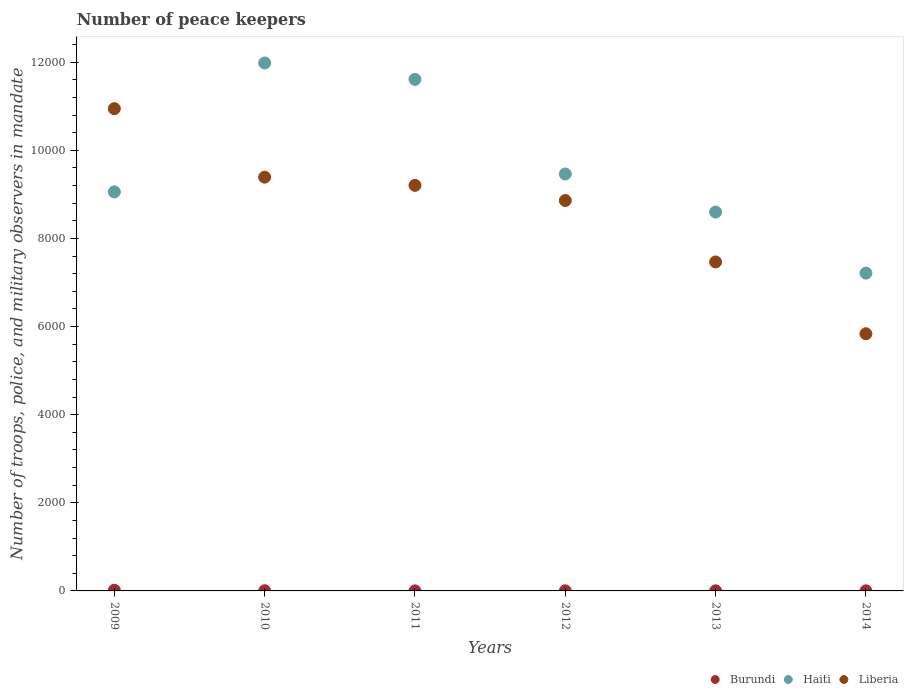How many different coloured dotlines are there?
Provide a succinct answer. 3. Across all years, what is the maximum number of peace keepers in in Haiti?
Offer a terse response. 1.20e+04. Across all years, what is the minimum number of peace keepers in in Haiti?
Offer a very short reply. 7213. What is the total number of peace keepers in in Liberia in the graph?
Your response must be concise. 5.17e+04. What is the difference between the number of peace keepers in in Liberia in 2012 and that in 2014?
Your response must be concise. 3024. What is the difference between the number of peace keepers in in Liberia in 2009 and the number of peace keepers in in Burundi in 2012?
Provide a succinct answer. 1.09e+04. What is the average number of peace keepers in in Haiti per year?
Provide a short and direct response. 9654.83. In the year 2013, what is the difference between the number of peace keepers in in Haiti and number of peace keepers in in Burundi?
Your answer should be compact. 8598. In how many years, is the number of peace keepers in in Liberia greater than 11600?
Provide a short and direct response. 0. What is the ratio of the number of peace keepers in in Haiti in 2010 to that in 2012?
Ensure brevity in your answer.  1.27. Is the number of peace keepers in in Liberia in 2013 less than that in 2014?
Keep it short and to the point. No. What is the difference between the highest and the second highest number of peace keepers in in Burundi?
Your answer should be compact. 11. Is the number of peace keepers in in Liberia strictly less than the number of peace keepers in in Haiti over the years?
Provide a succinct answer. No. How many dotlines are there?
Offer a very short reply. 3. Does the graph contain grids?
Your response must be concise. No. Where does the legend appear in the graph?
Provide a short and direct response. Bottom right. What is the title of the graph?
Provide a short and direct response. Number of peace keepers. Does "Belize" appear as one of the legend labels in the graph?
Your response must be concise. No. What is the label or title of the X-axis?
Your response must be concise. Years. What is the label or title of the Y-axis?
Ensure brevity in your answer.  Number of troops, police, and military observers in mandate. What is the Number of troops, police, and military observers in mandate in Burundi in 2009?
Offer a terse response. 15. What is the Number of troops, police, and military observers in mandate in Haiti in 2009?
Ensure brevity in your answer.  9057. What is the Number of troops, police, and military observers in mandate in Liberia in 2009?
Provide a short and direct response. 1.09e+04. What is the Number of troops, police, and military observers in mandate in Haiti in 2010?
Keep it short and to the point. 1.20e+04. What is the Number of troops, police, and military observers in mandate of Liberia in 2010?
Ensure brevity in your answer.  9392. What is the Number of troops, police, and military observers in mandate in Burundi in 2011?
Ensure brevity in your answer.  1. What is the Number of troops, police, and military observers in mandate in Haiti in 2011?
Your answer should be very brief. 1.16e+04. What is the Number of troops, police, and military observers in mandate in Liberia in 2011?
Offer a very short reply. 9206. What is the Number of troops, police, and military observers in mandate of Haiti in 2012?
Your answer should be very brief. 9464. What is the Number of troops, police, and military observers in mandate of Liberia in 2012?
Offer a very short reply. 8862. What is the Number of troops, police, and military observers in mandate in Burundi in 2013?
Make the answer very short. 2. What is the Number of troops, police, and military observers in mandate of Haiti in 2013?
Give a very brief answer. 8600. What is the Number of troops, police, and military observers in mandate of Liberia in 2013?
Provide a short and direct response. 7467. What is the Number of troops, police, and military observers in mandate of Haiti in 2014?
Offer a very short reply. 7213. What is the Number of troops, police, and military observers in mandate in Liberia in 2014?
Your response must be concise. 5838. Across all years, what is the maximum Number of troops, police, and military observers in mandate in Haiti?
Keep it short and to the point. 1.20e+04. Across all years, what is the maximum Number of troops, police, and military observers in mandate in Liberia?
Keep it short and to the point. 1.09e+04. Across all years, what is the minimum Number of troops, police, and military observers in mandate in Burundi?
Ensure brevity in your answer.  1. Across all years, what is the minimum Number of troops, police, and military observers in mandate of Haiti?
Provide a succinct answer. 7213. Across all years, what is the minimum Number of troops, police, and military observers in mandate in Liberia?
Provide a short and direct response. 5838. What is the total Number of troops, police, and military observers in mandate in Burundi in the graph?
Offer a very short reply. 26. What is the total Number of troops, police, and military observers in mandate of Haiti in the graph?
Give a very brief answer. 5.79e+04. What is the total Number of troops, police, and military observers in mandate in Liberia in the graph?
Provide a short and direct response. 5.17e+04. What is the difference between the Number of troops, police, and military observers in mandate in Haiti in 2009 and that in 2010?
Provide a short and direct response. -2927. What is the difference between the Number of troops, police, and military observers in mandate of Liberia in 2009 and that in 2010?
Your answer should be very brief. 1555. What is the difference between the Number of troops, police, and military observers in mandate in Haiti in 2009 and that in 2011?
Offer a very short reply. -2554. What is the difference between the Number of troops, police, and military observers in mandate in Liberia in 2009 and that in 2011?
Give a very brief answer. 1741. What is the difference between the Number of troops, police, and military observers in mandate in Burundi in 2009 and that in 2012?
Your response must be concise. 13. What is the difference between the Number of troops, police, and military observers in mandate in Haiti in 2009 and that in 2012?
Give a very brief answer. -407. What is the difference between the Number of troops, police, and military observers in mandate in Liberia in 2009 and that in 2012?
Make the answer very short. 2085. What is the difference between the Number of troops, police, and military observers in mandate of Burundi in 2009 and that in 2013?
Offer a terse response. 13. What is the difference between the Number of troops, police, and military observers in mandate in Haiti in 2009 and that in 2013?
Your answer should be compact. 457. What is the difference between the Number of troops, police, and military observers in mandate of Liberia in 2009 and that in 2013?
Offer a very short reply. 3480. What is the difference between the Number of troops, police, and military observers in mandate of Haiti in 2009 and that in 2014?
Provide a succinct answer. 1844. What is the difference between the Number of troops, police, and military observers in mandate in Liberia in 2009 and that in 2014?
Make the answer very short. 5109. What is the difference between the Number of troops, police, and military observers in mandate in Burundi in 2010 and that in 2011?
Offer a terse response. 3. What is the difference between the Number of troops, police, and military observers in mandate of Haiti in 2010 and that in 2011?
Provide a succinct answer. 373. What is the difference between the Number of troops, police, and military observers in mandate of Liberia in 2010 and that in 2011?
Your answer should be very brief. 186. What is the difference between the Number of troops, police, and military observers in mandate of Haiti in 2010 and that in 2012?
Your answer should be very brief. 2520. What is the difference between the Number of troops, police, and military observers in mandate in Liberia in 2010 and that in 2012?
Your answer should be compact. 530. What is the difference between the Number of troops, police, and military observers in mandate in Burundi in 2010 and that in 2013?
Provide a short and direct response. 2. What is the difference between the Number of troops, police, and military observers in mandate of Haiti in 2010 and that in 2013?
Ensure brevity in your answer.  3384. What is the difference between the Number of troops, police, and military observers in mandate of Liberia in 2010 and that in 2013?
Your response must be concise. 1925. What is the difference between the Number of troops, police, and military observers in mandate of Haiti in 2010 and that in 2014?
Provide a succinct answer. 4771. What is the difference between the Number of troops, police, and military observers in mandate in Liberia in 2010 and that in 2014?
Offer a terse response. 3554. What is the difference between the Number of troops, police, and military observers in mandate in Burundi in 2011 and that in 2012?
Give a very brief answer. -1. What is the difference between the Number of troops, police, and military observers in mandate in Haiti in 2011 and that in 2012?
Give a very brief answer. 2147. What is the difference between the Number of troops, police, and military observers in mandate of Liberia in 2011 and that in 2012?
Your response must be concise. 344. What is the difference between the Number of troops, police, and military observers in mandate in Burundi in 2011 and that in 2013?
Offer a very short reply. -1. What is the difference between the Number of troops, police, and military observers in mandate of Haiti in 2011 and that in 2013?
Give a very brief answer. 3011. What is the difference between the Number of troops, police, and military observers in mandate of Liberia in 2011 and that in 2013?
Your answer should be very brief. 1739. What is the difference between the Number of troops, police, and military observers in mandate in Haiti in 2011 and that in 2014?
Offer a terse response. 4398. What is the difference between the Number of troops, police, and military observers in mandate of Liberia in 2011 and that in 2014?
Provide a succinct answer. 3368. What is the difference between the Number of troops, police, and military observers in mandate of Burundi in 2012 and that in 2013?
Make the answer very short. 0. What is the difference between the Number of troops, police, and military observers in mandate of Haiti in 2012 and that in 2013?
Provide a short and direct response. 864. What is the difference between the Number of troops, police, and military observers in mandate in Liberia in 2012 and that in 2013?
Keep it short and to the point. 1395. What is the difference between the Number of troops, police, and military observers in mandate of Haiti in 2012 and that in 2014?
Your response must be concise. 2251. What is the difference between the Number of troops, police, and military observers in mandate of Liberia in 2012 and that in 2014?
Give a very brief answer. 3024. What is the difference between the Number of troops, police, and military observers in mandate in Burundi in 2013 and that in 2014?
Make the answer very short. 0. What is the difference between the Number of troops, police, and military observers in mandate in Haiti in 2013 and that in 2014?
Provide a short and direct response. 1387. What is the difference between the Number of troops, police, and military observers in mandate in Liberia in 2013 and that in 2014?
Provide a succinct answer. 1629. What is the difference between the Number of troops, police, and military observers in mandate in Burundi in 2009 and the Number of troops, police, and military observers in mandate in Haiti in 2010?
Make the answer very short. -1.20e+04. What is the difference between the Number of troops, police, and military observers in mandate of Burundi in 2009 and the Number of troops, police, and military observers in mandate of Liberia in 2010?
Provide a succinct answer. -9377. What is the difference between the Number of troops, police, and military observers in mandate in Haiti in 2009 and the Number of troops, police, and military observers in mandate in Liberia in 2010?
Offer a very short reply. -335. What is the difference between the Number of troops, police, and military observers in mandate of Burundi in 2009 and the Number of troops, police, and military observers in mandate of Haiti in 2011?
Provide a succinct answer. -1.16e+04. What is the difference between the Number of troops, police, and military observers in mandate of Burundi in 2009 and the Number of troops, police, and military observers in mandate of Liberia in 2011?
Keep it short and to the point. -9191. What is the difference between the Number of troops, police, and military observers in mandate of Haiti in 2009 and the Number of troops, police, and military observers in mandate of Liberia in 2011?
Keep it short and to the point. -149. What is the difference between the Number of troops, police, and military observers in mandate of Burundi in 2009 and the Number of troops, police, and military observers in mandate of Haiti in 2012?
Provide a succinct answer. -9449. What is the difference between the Number of troops, police, and military observers in mandate of Burundi in 2009 and the Number of troops, police, and military observers in mandate of Liberia in 2012?
Offer a very short reply. -8847. What is the difference between the Number of troops, police, and military observers in mandate of Haiti in 2009 and the Number of troops, police, and military observers in mandate of Liberia in 2012?
Provide a succinct answer. 195. What is the difference between the Number of troops, police, and military observers in mandate in Burundi in 2009 and the Number of troops, police, and military observers in mandate in Haiti in 2013?
Offer a terse response. -8585. What is the difference between the Number of troops, police, and military observers in mandate of Burundi in 2009 and the Number of troops, police, and military observers in mandate of Liberia in 2013?
Give a very brief answer. -7452. What is the difference between the Number of troops, police, and military observers in mandate in Haiti in 2009 and the Number of troops, police, and military observers in mandate in Liberia in 2013?
Give a very brief answer. 1590. What is the difference between the Number of troops, police, and military observers in mandate in Burundi in 2009 and the Number of troops, police, and military observers in mandate in Haiti in 2014?
Your answer should be compact. -7198. What is the difference between the Number of troops, police, and military observers in mandate of Burundi in 2009 and the Number of troops, police, and military observers in mandate of Liberia in 2014?
Your response must be concise. -5823. What is the difference between the Number of troops, police, and military observers in mandate of Haiti in 2009 and the Number of troops, police, and military observers in mandate of Liberia in 2014?
Make the answer very short. 3219. What is the difference between the Number of troops, police, and military observers in mandate of Burundi in 2010 and the Number of troops, police, and military observers in mandate of Haiti in 2011?
Ensure brevity in your answer.  -1.16e+04. What is the difference between the Number of troops, police, and military observers in mandate in Burundi in 2010 and the Number of troops, police, and military observers in mandate in Liberia in 2011?
Offer a terse response. -9202. What is the difference between the Number of troops, police, and military observers in mandate of Haiti in 2010 and the Number of troops, police, and military observers in mandate of Liberia in 2011?
Give a very brief answer. 2778. What is the difference between the Number of troops, police, and military observers in mandate of Burundi in 2010 and the Number of troops, police, and military observers in mandate of Haiti in 2012?
Provide a succinct answer. -9460. What is the difference between the Number of troops, police, and military observers in mandate in Burundi in 2010 and the Number of troops, police, and military observers in mandate in Liberia in 2012?
Provide a succinct answer. -8858. What is the difference between the Number of troops, police, and military observers in mandate in Haiti in 2010 and the Number of troops, police, and military observers in mandate in Liberia in 2012?
Offer a terse response. 3122. What is the difference between the Number of troops, police, and military observers in mandate of Burundi in 2010 and the Number of troops, police, and military observers in mandate of Haiti in 2013?
Ensure brevity in your answer.  -8596. What is the difference between the Number of troops, police, and military observers in mandate of Burundi in 2010 and the Number of troops, police, and military observers in mandate of Liberia in 2013?
Offer a very short reply. -7463. What is the difference between the Number of troops, police, and military observers in mandate in Haiti in 2010 and the Number of troops, police, and military observers in mandate in Liberia in 2013?
Offer a very short reply. 4517. What is the difference between the Number of troops, police, and military observers in mandate of Burundi in 2010 and the Number of troops, police, and military observers in mandate of Haiti in 2014?
Offer a terse response. -7209. What is the difference between the Number of troops, police, and military observers in mandate in Burundi in 2010 and the Number of troops, police, and military observers in mandate in Liberia in 2014?
Provide a succinct answer. -5834. What is the difference between the Number of troops, police, and military observers in mandate in Haiti in 2010 and the Number of troops, police, and military observers in mandate in Liberia in 2014?
Give a very brief answer. 6146. What is the difference between the Number of troops, police, and military observers in mandate of Burundi in 2011 and the Number of troops, police, and military observers in mandate of Haiti in 2012?
Your response must be concise. -9463. What is the difference between the Number of troops, police, and military observers in mandate of Burundi in 2011 and the Number of troops, police, and military observers in mandate of Liberia in 2012?
Offer a very short reply. -8861. What is the difference between the Number of troops, police, and military observers in mandate of Haiti in 2011 and the Number of troops, police, and military observers in mandate of Liberia in 2012?
Your response must be concise. 2749. What is the difference between the Number of troops, police, and military observers in mandate of Burundi in 2011 and the Number of troops, police, and military observers in mandate of Haiti in 2013?
Keep it short and to the point. -8599. What is the difference between the Number of troops, police, and military observers in mandate in Burundi in 2011 and the Number of troops, police, and military observers in mandate in Liberia in 2013?
Keep it short and to the point. -7466. What is the difference between the Number of troops, police, and military observers in mandate of Haiti in 2011 and the Number of troops, police, and military observers in mandate of Liberia in 2013?
Your answer should be very brief. 4144. What is the difference between the Number of troops, police, and military observers in mandate of Burundi in 2011 and the Number of troops, police, and military observers in mandate of Haiti in 2014?
Make the answer very short. -7212. What is the difference between the Number of troops, police, and military observers in mandate in Burundi in 2011 and the Number of troops, police, and military observers in mandate in Liberia in 2014?
Your answer should be very brief. -5837. What is the difference between the Number of troops, police, and military observers in mandate of Haiti in 2011 and the Number of troops, police, and military observers in mandate of Liberia in 2014?
Provide a short and direct response. 5773. What is the difference between the Number of troops, police, and military observers in mandate in Burundi in 2012 and the Number of troops, police, and military observers in mandate in Haiti in 2013?
Offer a terse response. -8598. What is the difference between the Number of troops, police, and military observers in mandate of Burundi in 2012 and the Number of troops, police, and military observers in mandate of Liberia in 2013?
Give a very brief answer. -7465. What is the difference between the Number of troops, police, and military observers in mandate in Haiti in 2012 and the Number of troops, police, and military observers in mandate in Liberia in 2013?
Give a very brief answer. 1997. What is the difference between the Number of troops, police, and military observers in mandate of Burundi in 2012 and the Number of troops, police, and military observers in mandate of Haiti in 2014?
Offer a very short reply. -7211. What is the difference between the Number of troops, police, and military observers in mandate in Burundi in 2012 and the Number of troops, police, and military observers in mandate in Liberia in 2014?
Your response must be concise. -5836. What is the difference between the Number of troops, police, and military observers in mandate in Haiti in 2012 and the Number of troops, police, and military observers in mandate in Liberia in 2014?
Offer a terse response. 3626. What is the difference between the Number of troops, police, and military observers in mandate in Burundi in 2013 and the Number of troops, police, and military observers in mandate in Haiti in 2014?
Your answer should be very brief. -7211. What is the difference between the Number of troops, police, and military observers in mandate in Burundi in 2013 and the Number of troops, police, and military observers in mandate in Liberia in 2014?
Your answer should be compact. -5836. What is the difference between the Number of troops, police, and military observers in mandate of Haiti in 2013 and the Number of troops, police, and military observers in mandate of Liberia in 2014?
Give a very brief answer. 2762. What is the average Number of troops, police, and military observers in mandate of Burundi per year?
Your answer should be very brief. 4.33. What is the average Number of troops, police, and military observers in mandate in Haiti per year?
Make the answer very short. 9654.83. What is the average Number of troops, police, and military observers in mandate in Liberia per year?
Give a very brief answer. 8618.67. In the year 2009, what is the difference between the Number of troops, police, and military observers in mandate of Burundi and Number of troops, police, and military observers in mandate of Haiti?
Your response must be concise. -9042. In the year 2009, what is the difference between the Number of troops, police, and military observers in mandate in Burundi and Number of troops, police, and military observers in mandate in Liberia?
Give a very brief answer. -1.09e+04. In the year 2009, what is the difference between the Number of troops, police, and military observers in mandate of Haiti and Number of troops, police, and military observers in mandate of Liberia?
Offer a very short reply. -1890. In the year 2010, what is the difference between the Number of troops, police, and military observers in mandate of Burundi and Number of troops, police, and military observers in mandate of Haiti?
Your answer should be very brief. -1.20e+04. In the year 2010, what is the difference between the Number of troops, police, and military observers in mandate in Burundi and Number of troops, police, and military observers in mandate in Liberia?
Ensure brevity in your answer.  -9388. In the year 2010, what is the difference between the Number of troops, police, and military observers in mandate in Haiti and Number of troops, police, and military observers in mandate in Liberia?
Your response must be concise. 2592. In the year 2011, what is the difference between the Number of troops, police, and military observers in mandate of Burundi and Number of troops, police, and military observers in mandate of Haiti?
Make the answer very short. -1.16e+04. In the year 2011, what is the difference between the Number of troops, police, and military observers in mandate of Burundi and Number of troops, police, and military observers in mandate of Liberia?
Provide a short and direct response. -9205. In the year 2011, what is the difference between the Number of troops, police, and military observers in mandate in Haiti and Number of troops, police, and military observers in mandate in Liberia?
Ensure brevity in your answer.  2405. In the year 2012, what is the difference between the Number of troops, police, and military observers in mandate in Burundi and Number of troops, police, and military observers in mandate in Haiti?
Make the answer very short. -9462. In the year 2012, what is the difference between the Number of troops, police, and military observers in mandate in Burundi and Number of troops, police, and military observers in mandate in Liberia?
Keep it short and to the point. -8860. In the year 2012, what is the difference between the Number of troops, police, and military observers in mandate of Haiti and Number of troops, police, and military observers in mandate of Liberia?
Your response must be concise. 602. In the year 2013, what is the difference between the Number of troops, police, and military observers in mandate of Burundi and Number of troops, police, and military observers in mandate of Haiti?
Your answer should be compact. -8598. In the year 2013, what is the difference between the Number of troops, police, and military observers in mandate of Burundi and Number of troops, police, and military observers in mandate of Liberia?
Your response must be concise. -7465. In the year 2013, what is the difference between the Number of troops, police, and military observers in mandate in Haiti and Number of troops, police, and military observers in mandate in Liberia?
Ensure brevity in your answer.  1133. In the year 2014, what is the difference between the Number of troops, police, and military observers in mandate of Burundi and Number of troops, police, and military observers in mandate of Haiti?
Provide a succinct answer. -7211. In the year 2014, what is the difference between the Number of troops, police, and military observers in mandate of Burundi and Number of troops, police, and military observers in mandate of Liberia?
Offer a terse response. -5836. In the year 2014, what is the difference between the Number of troops, police, and military observers in mandate of Haiti and Number of troops, police, and military observers in mandate of Liberia?
Offer a terse response. 1375. What is the ratio of the Number of troops, police, and military observers in mandate of Burundi in 2009 to that in 2010?
Ensure brevity in your answer.  3.75. What is the ratio of the Number of troops, police, and military observers in mandate in Haiti in 2009 to that in 2010?
Your answer should be compact. 0.76. What is the ratio of the Number of troops, police, and military observers in mandate of Liberia in 2009 to that in 2010?
Your answer should be compact. 1.17. What is the ratio of the Number of troops, police, and military observers in mandate of Haiti in 2009 to that in 2011?
Your answer should be compact. 0.78. What is the ratio of the Number of troops, police, and military observers in mandate of Liberia in 2009 to that in 2011?
Provide a short and direct response. 1.19. What is the ratio of the Number of troops, police, and military observers in mandate in Burundi in 2009 to that in 2012?
Keep it short and to the point. 7.5. What is the ratio of the Number of troops, police, and military observers in mandate in Haiti in 2009 to that in 2012?
Make the answer very short. 0.96. What is the ratio of the Number of troops, police, and military observers in mandate of Liberia in 2009 to that in 2012?
Your answer should be compact. 1.24. What is the ratio of the Number of troops, police, and military observers in mandate of Haiti in 2009 to that in 2013?
Offer a very short reply. 1.05. What is the ratio of the Number of troops, police, and military observers in mandate in Liberia in 2009 to that in 2013?
Your answer should be compact. 1.47. What is the ratio of the Number of troops, police, and military observers in mandate of Burundi in 2009 to that in 2014?
Offer a very short reply. 7.5. What is the ratio of the Number of troops, police, and military observers in mandate of Haiti in 2009 to that in 2014?
Provide a short and direct response. 1.26. What is the ratio of the Number of troops, police, and military observers in mandate of Liberia in 2009 to that in 2014?
Provide a short and direct response. 1.88. What is the ratio of the Number of troops, police, and military observers in mandate of Burundi in 2010 to that in 2011?
Offer a very short reply. 4. What is the ratio of the Number of troops, police, and military observers in mandate of Haiti in 2010 to that in 2011?
Provide a short and direct response. 1.03. What is the ratio of the Number of troops, police, and military observers in mandate in Liberia in 2010 to that in 2011?
Keep it short and to the point. 1.02. What is the ratio of the Number of troops, police, and military observers in mandate in Burundi in 2010 to that in 2012?
Your answer should be very brief. 2. What is the ratio of the Number of troops, police, and military observers in mandate of Haiti in 2010 to that in 2012?
Keep it short and to the point. 1.27. What is the ratio of the Number of troops, police, and military observers in mandate of Liberia in 2010 to that in 2012?
Provide a succinct answer. 1.06. What is the ratio of the Number of troops, police, and military observers in mandate of Burundi in 2010 to that in 2013?
Keep it short and to the point. 2. What is the ratio of the Number of troops, police, and military observers in mandate in Haiti in 2010 to that in 2013?
Offer a very short reply. 1.39. What is the ratio of the Number of troops, police, and military observers in mandate of Liberia in 2010 to that in 2013?
Provide a short and direct response. 1.26. What is the ratio of the Number of troops, police, and military observers in mandate of Haiti in 2010 to that in 2014?
Ensure brevity in your answer.  1.66. What is the ratio of the Number of troops, police, and military observers in mandate in Liberia in 2010 to that in 2014?
Offer a very short reply. 1.61. What is the ratio of the Number of troops, police, and military observers in mandate of Haiti in 2011 to that in 2012?
Provide a succinct answer. 1.23. What is the ratio of the Number of troops, police, and military observers in mandate in Liberia in 2011 to that in 2012?
Ensure brevity in your answer.  1.04. What is the ratio of the Number of troops, police, and military observers in mandate of Burundi in 2011 to that in 2013?
Provide a succinct answer. 0.5. What is the ratio of the Number of troops, police, and military observers in mandate in Haiti in 2011 to that in 2013?
Offer a very short reply. 1.35. What is the ratio of the Number of troops, police, and military observers in mandate of Liberia in 2011 to that in 2013?
Ensure brevity in your answer.  1.23. What is the ratio of the Number of troops, police, and military observers in mandate of Burundi in 2011 to that in 2014?
Make the answer very short. 0.5. What is the ratio of the Number of troops, police, and military observers in mandate of Haiti in 2011 to that in 2014?
Give a very brief answer. 1.61. What is the ratio of the Number of troops, police, and military observers in mandate in Liberia in 2011 to that in 2014?
Provide a short and direct response. 1.58. What is the ratio of the Number of troops, police, and military observers in mandate in Haiti in 2012 to that in 2013?
Offer a terse response. 1.1. What is the ratio of the Number of troops, police, and military observers in mandate of Liberia in 2012 to that in 2013?
Offer a very short reply. 1.19. What is the ratio of the Number of troops, police, and military observers in mandate in Burundi in 2012 to that in 2014?
Ensure brevity in your answer.  1. What is the ratio of the Number of troops, police, and military observers in mandate of Haiti in 2012 to that in 2014?
Offer a very short reply. 1.31. What is the ratio of the Number of troops, police, and military observers in mandate of Liberia in 2012 to that in 2014?
Provide a succinct answer. 1.52. What is the ratio of the Number of troops, police, and military observers in mandate in Burundi in 2013 to that in 2014?
Your answer should be very brief. 1. What is the ratio of the Number of troops, police, and military observers in mandate in Haiti in 2013 to that in 2014?
Give a very brief answer. 1.19. What is the ratio of the Number of troops, police, and military observers in mandate in Liberia in 2013 to that in 2014?
Offer a very short reply. 1.28. What is the difference between the highest and the second highest Number of troops, police, and military observers in mandate of Burundi?
Make the answer very short. 11. What is the difference between the highest and the second highest Number of troops, police, and military observers in mandate of Haiti?
Your response must be concise. 373. What is the difference between the highest and the second highest Number of troops, police, and military observers in mandate in Liberia?
Give a very brief answer. 1555. What is the difference between the highest and the lowest Number of troops, police, and military observers in mandate in Haiti?
Provide a succinct answer. 4771. What is the difference between the highest and the lowest Number of troops, police, and military observers in mandate of Liberia?
Your response must be concise. 5109. 